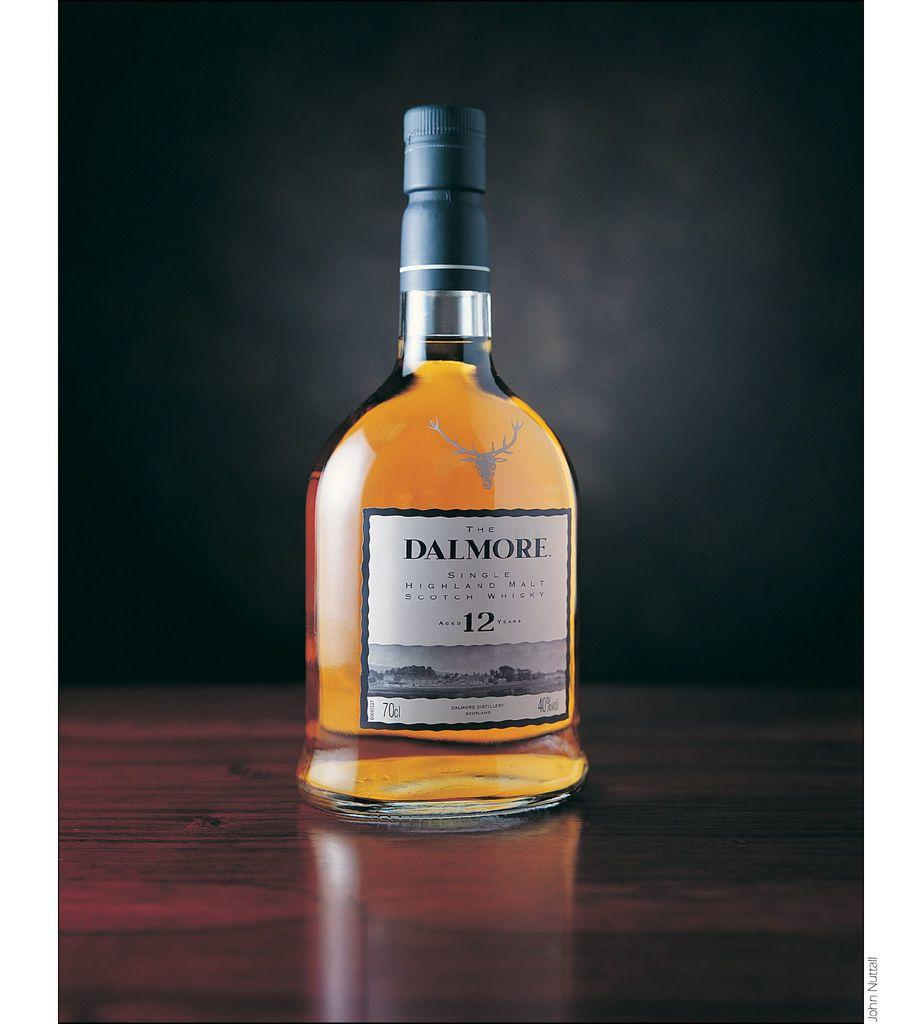<image>
Describe the image concisely. A Dalmore single malt has a stag logo on it. 